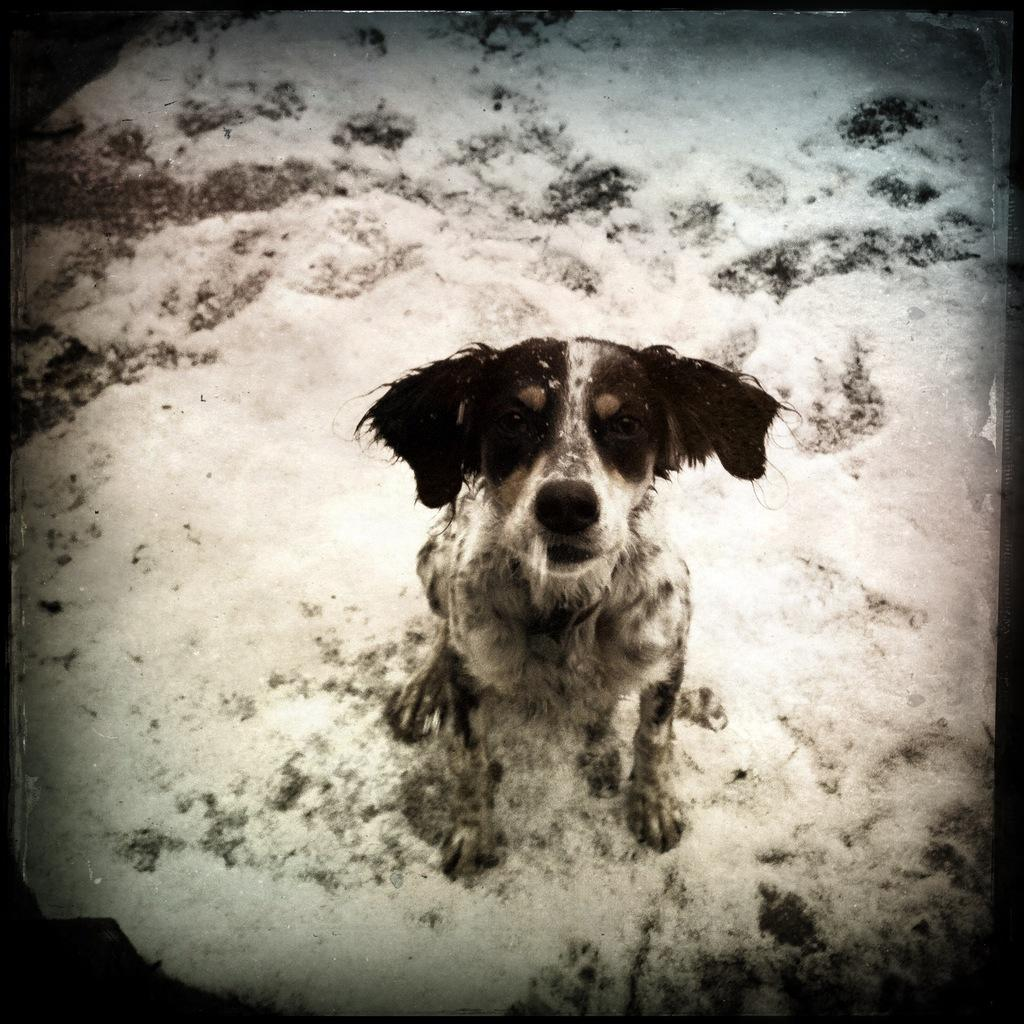What animal is present in the image? There is a dog in the image. Where is the dog located? The dog is sitting on the snow. What is the dog looking at? The dog is looking at a picture. What type of mask is the dog wearing in the image? There is no mask present on the dog in the image. What color are the dog's trousers in the image? Dogs do not wear trousers, so this question cannot be answered. 